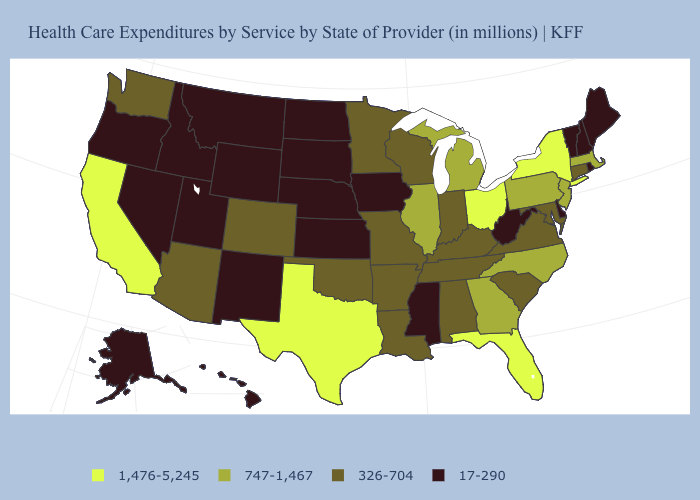Name the states that have a value in the range 17-290?
Quick response, please. Alaska, Delaware, Hawaii, Idaho, Iowa, Kansas, Maine, Mississippi, Montana, Nebraska, Nevada, New Hampshire, New Mexico, North Dakota, Oregon, Rhode Island, South Dakota, Utah, Vermont, West Virginia, Wyoming. Does California have the highest value in the USA?
Answer briefly. Yes. What is the highest value in states that border Maine?
Short answer required. 17-290. Does Florida have the highest value in the South?
Keep it brief. Yes. What is the value of Connecticut?
Be succinct. 326-704. Does the map have missing data?
Write a very short answer. No. What is the value of California?
Write a very short answer. 1,476-5,245. What is the value of Delaware?
Short answer required. 17-290. What is the value of Illinois?
Keep it brief. 747-1,467. What is the value of Massachusetts?
Be succinct. 747-1,467. Name the states that have a value in the range 17-290?
Quick response, please. Alaska, Delaware, Hawaii, Idaho, Iowa, Kansas, Maine, Mississippi, Montana, Nebraska, Nevada, New Hampshire, New Mexico, North Dakota, Oregon, Rhode Island, South Dakota, Utah, Vermont, West Virginia, Wyoming. Among the states that border Massachusetts , does Connecticut have the lowest value?
Answer briefly. No. What is the value of South Carolina?
Answer briefly. 326-704. What is the highest value in states that border New Mexico?
Keep it brief. 1,476-5,245. Which states have the lowest value in the USA?
Concise answer only. Alaska, Delaware, Hawaii, Idaho, Iowa, Kansas, Maine, Mississippi, Montana, Nebraska, Nevada, New Hampshire, New Mexico, North Dakota, Oregon, Rhode Island, South Dakota, Utah, Vermont, West Virginia, Wyoming. 